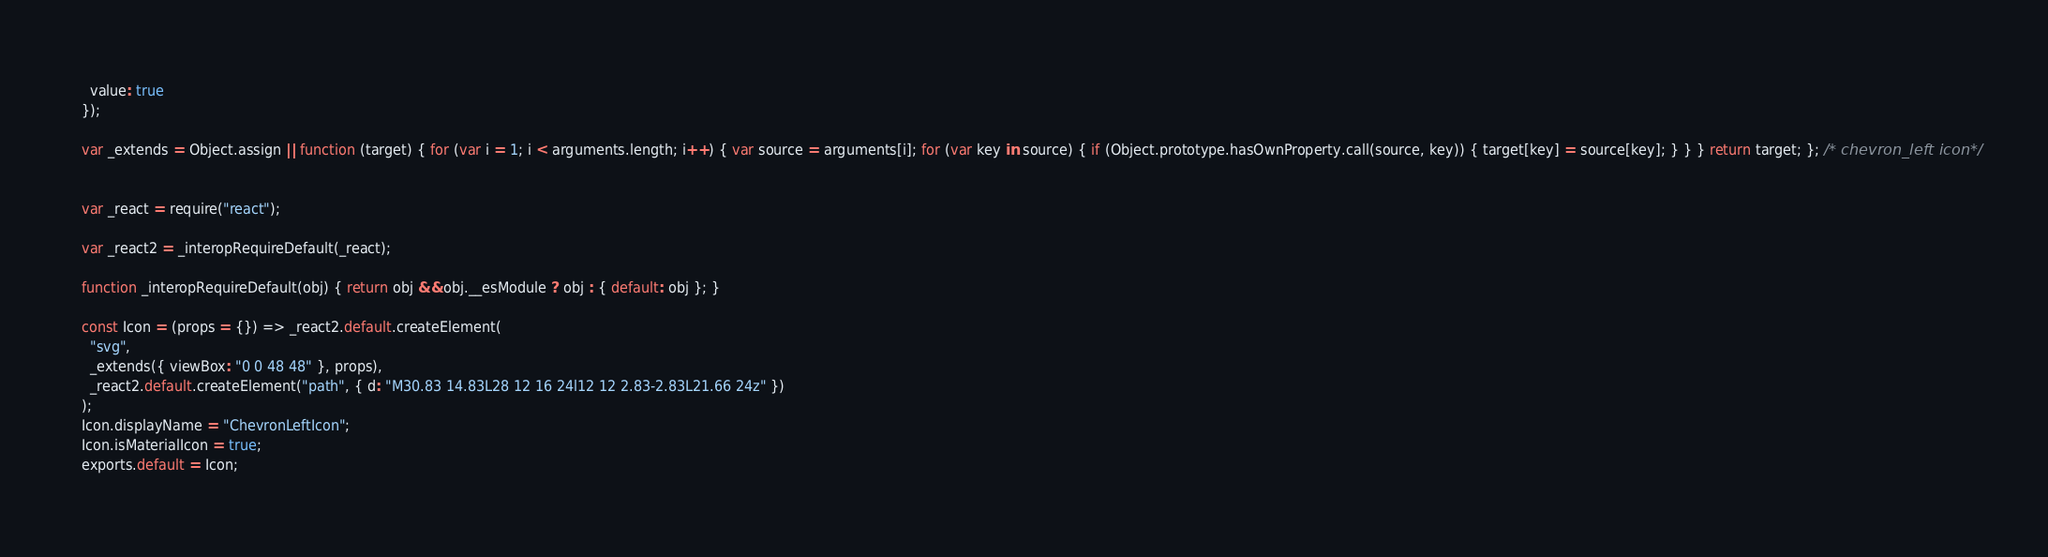<code> <loc_0><loc_0><loc_500><loc_500><_JavaScript_>  value: true
});

var _extends = Object.assign || function (target) { for (var i = 1; i < arguments.length; i++) { var source = arguments[i]; for (var key in source) { if (Object.prototype.hasOwnProperty.call(source, key)) { target[key] = source[key]; } } } return target; }; /* chevron_left icon*/


var _react = require("react");

var _react2 = _interopRequireDefault(_react);

function _interopRequireDefault(obj) { return obj && obj.__esModule ? obj : { default: obj }; }

const Icon = (props = {}) => _react2.default.createElement(
  "svg",
  _extends({ viewBox: "0 0 48 48" }, props),
  _react2.default.createElement("path", { d: "M30.83 14.83L28 12 16 24l12 12 2.83-2.83L21.66 24z" })
);
Icon.displayName = "ChevronLeftIcon";
Icon.isMaterialIcon = true;
exports.default = Icon;</code> 